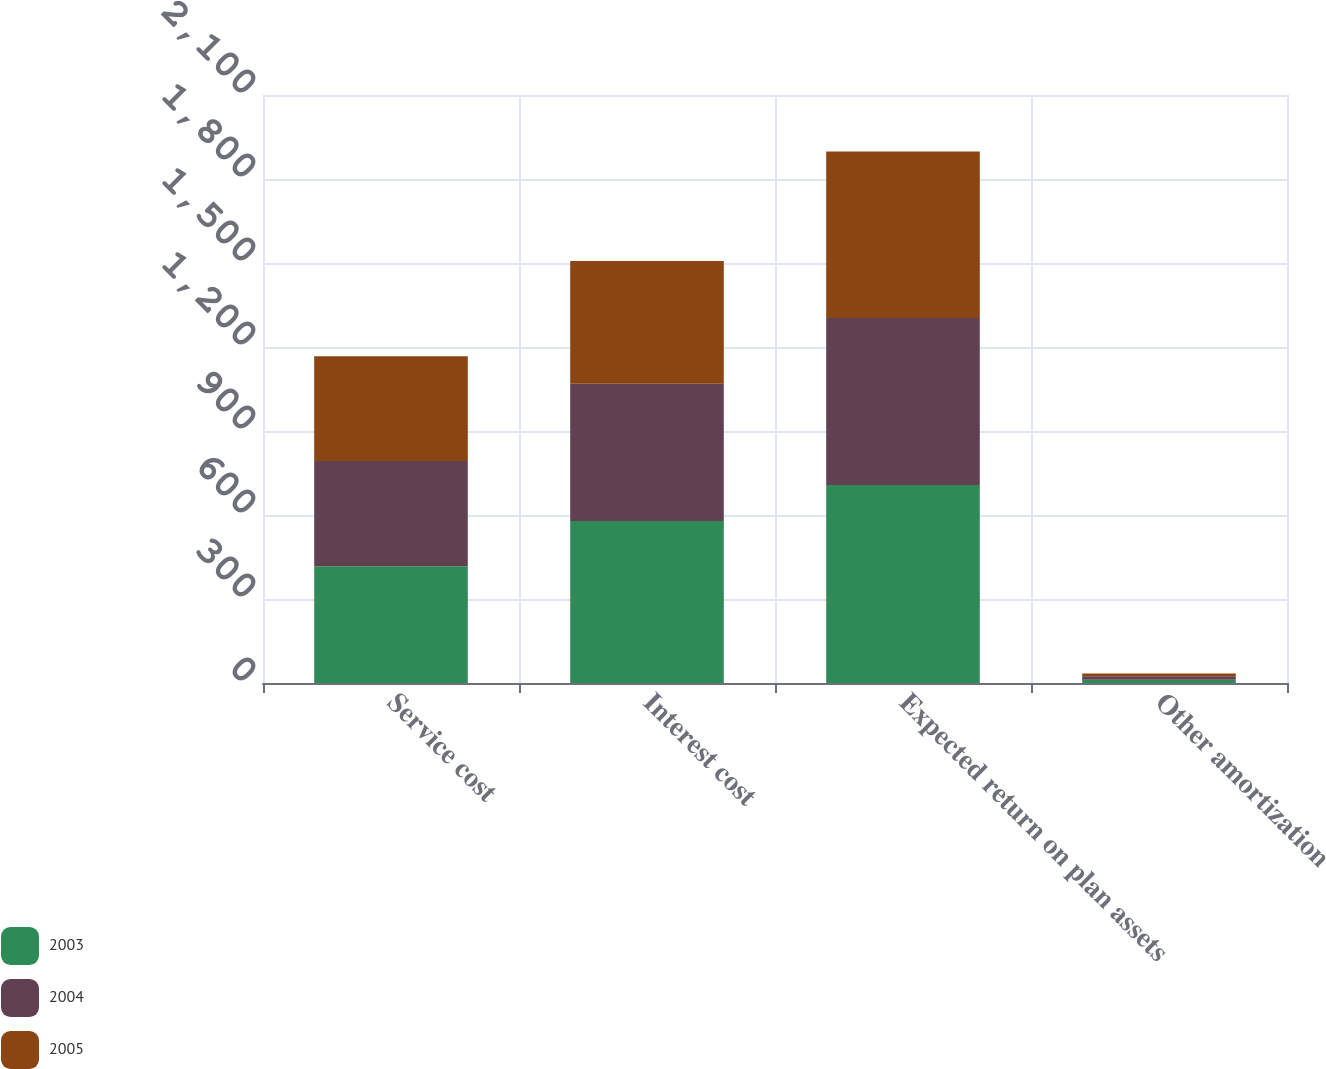<chart> <loc_0><loc_0><loc_500><loc_500><stacked_bar_chart><ecel><fcel>Service cost<fcel>Interest cost<fcel>Expected return on plan assets<fcel>Other amortization<nl><fcel>2003<fcel>417<fcel>579<fcel>707<fcel>12<nl><fcel>2004<fcel>376<fcel>490<fcel>597<fcel>12<nl><fcel>2005<fcel>374<fcel>438<fcel>594<fcel>10<nl></chart> 